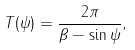<formula> <loc_0><loc_0><loc_500><loc_500>T ( \psi ) = \frac { 2 \pi } { \beta - \sin \psi } ,</formula> 